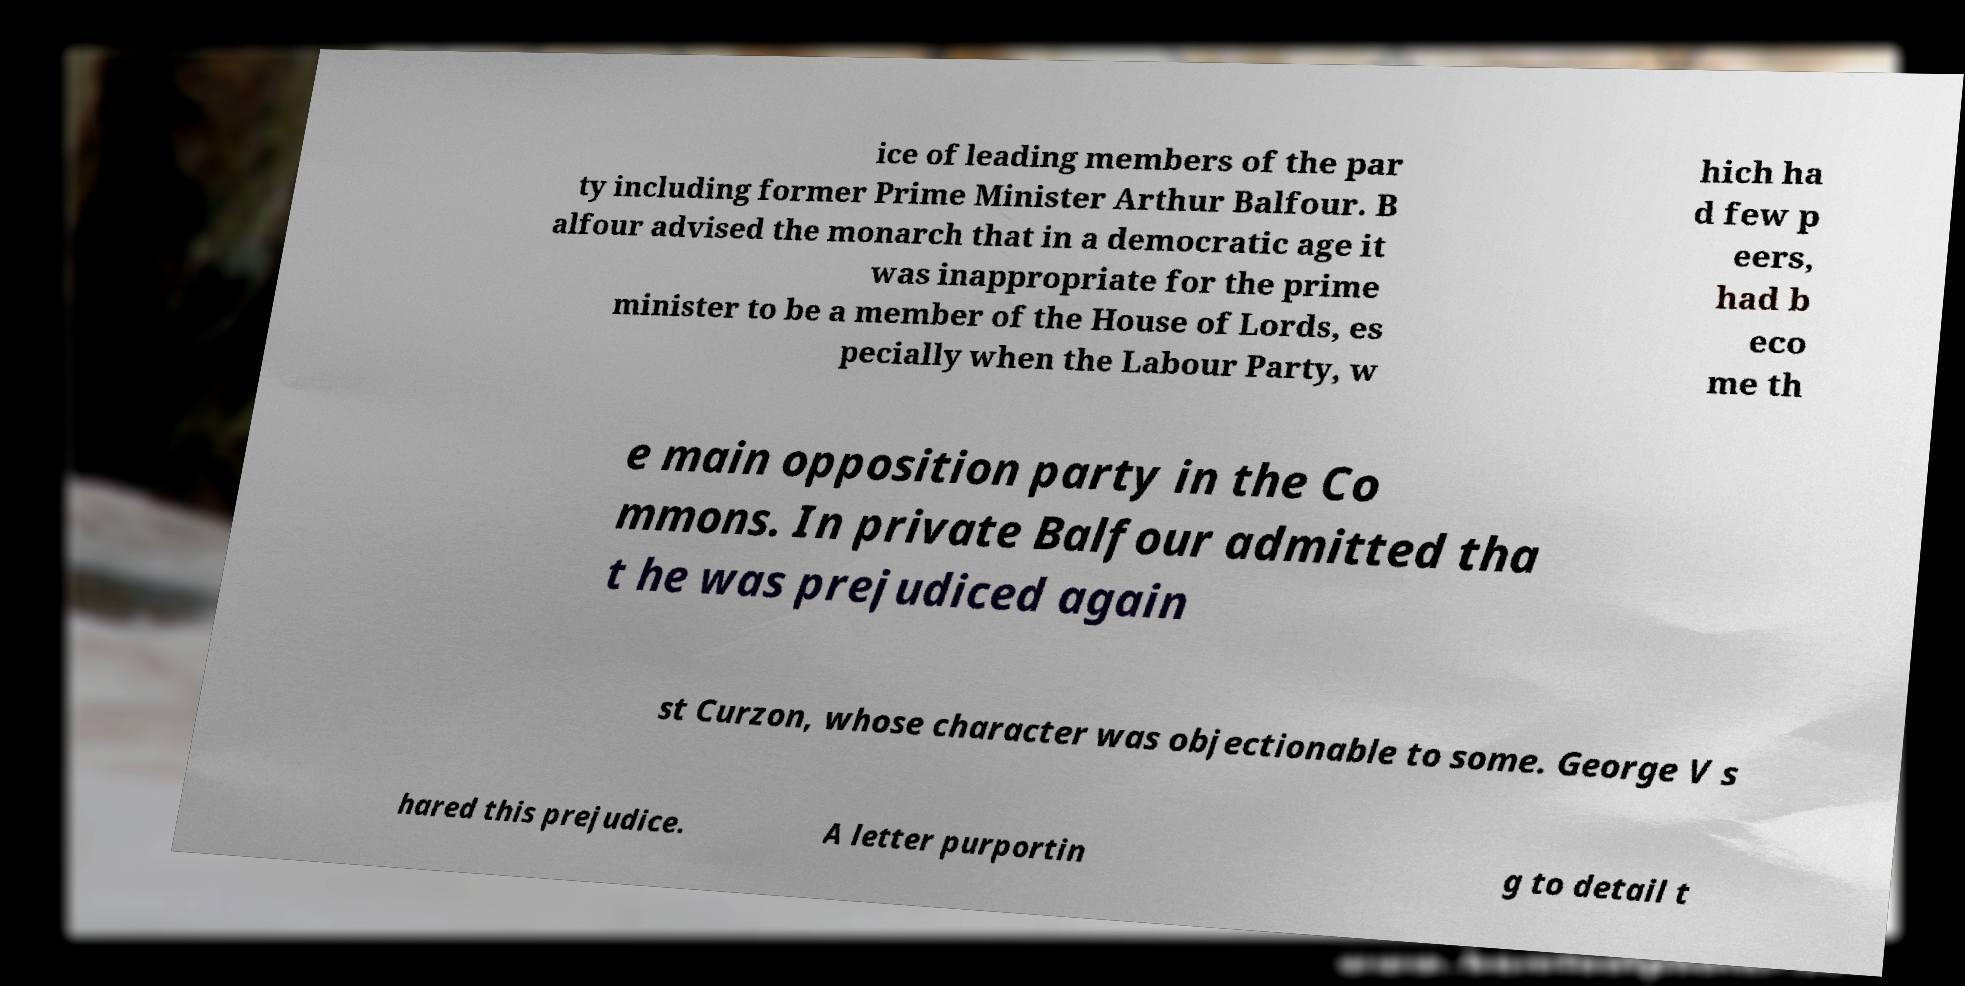Could you assist in decoding the text presented in this image and type it out clearly? ice of leading members of the par ty including former Prime Minister Arthur Balfour. B alfour advised the monarch that in a democratic age it was inappropriate for the prime minister to be a member of the House of Lords, es pecially when the Labour Party, w hich ha d few p eers, had b eco me th e main opposition party in the Co mmons. In private Balfour admitted tha t he was prejudiced again st Curzon, whose character was objectionable to some. George V s hared this prejudice. A letter purportin g to detail t 